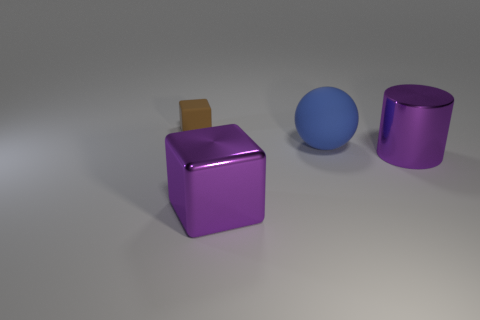Add 4 green shiny spheres. How many objects exist? 8 Subtract all cylinders. How many objects are left? 3 Subtract all large matte spheres. Subtract all large cylinders. How many objects are left? 2 Add 4 brown matte objects. How many brown matte objects are left? 5 Add 2 purple cylinders. How many purple cylinders exist? 3 Subtract 0 cyan cylinders. How many objects are left? 4 